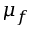<formula> <loc_0><loc_0><loc_500><loc_500>\mu _ { f }</formula> 